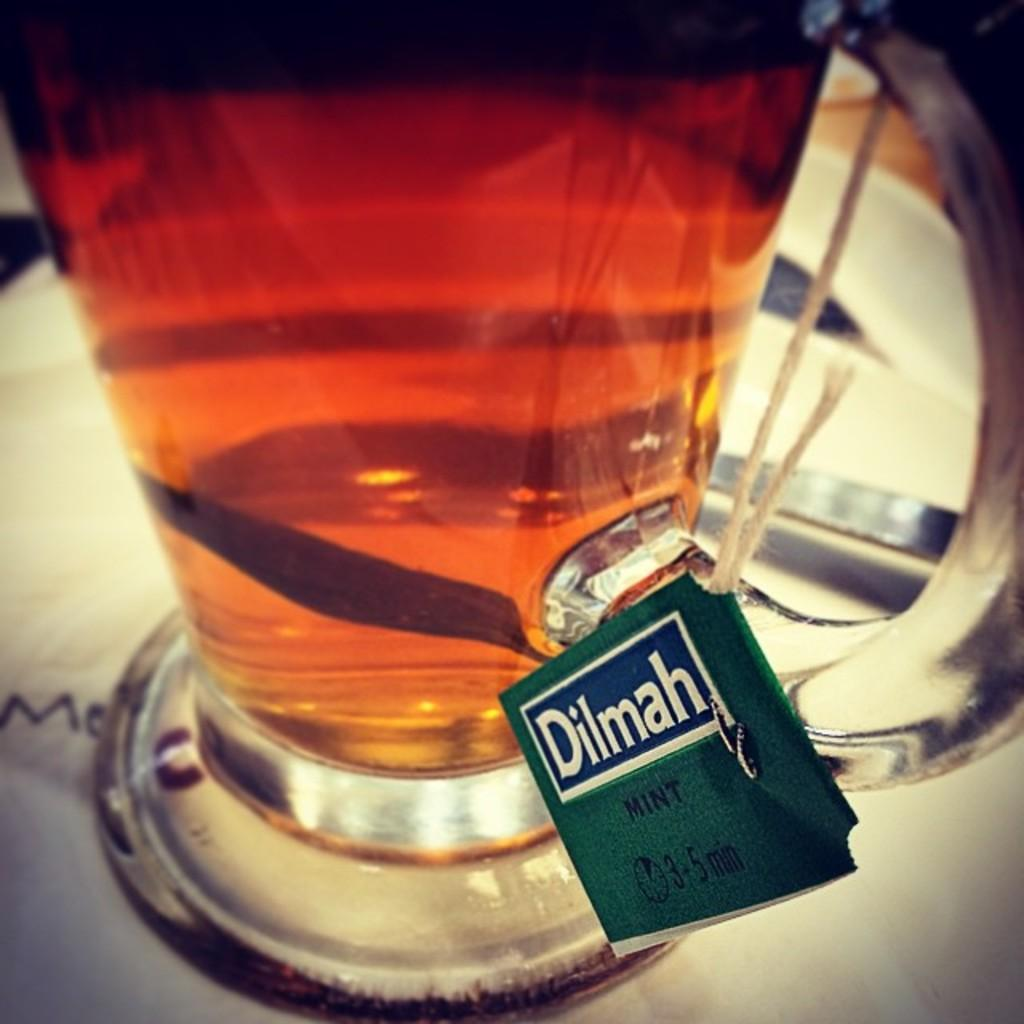Provide a one-sentence caption for the provided image. A picher with a tag that reads Dilmah Mint. 